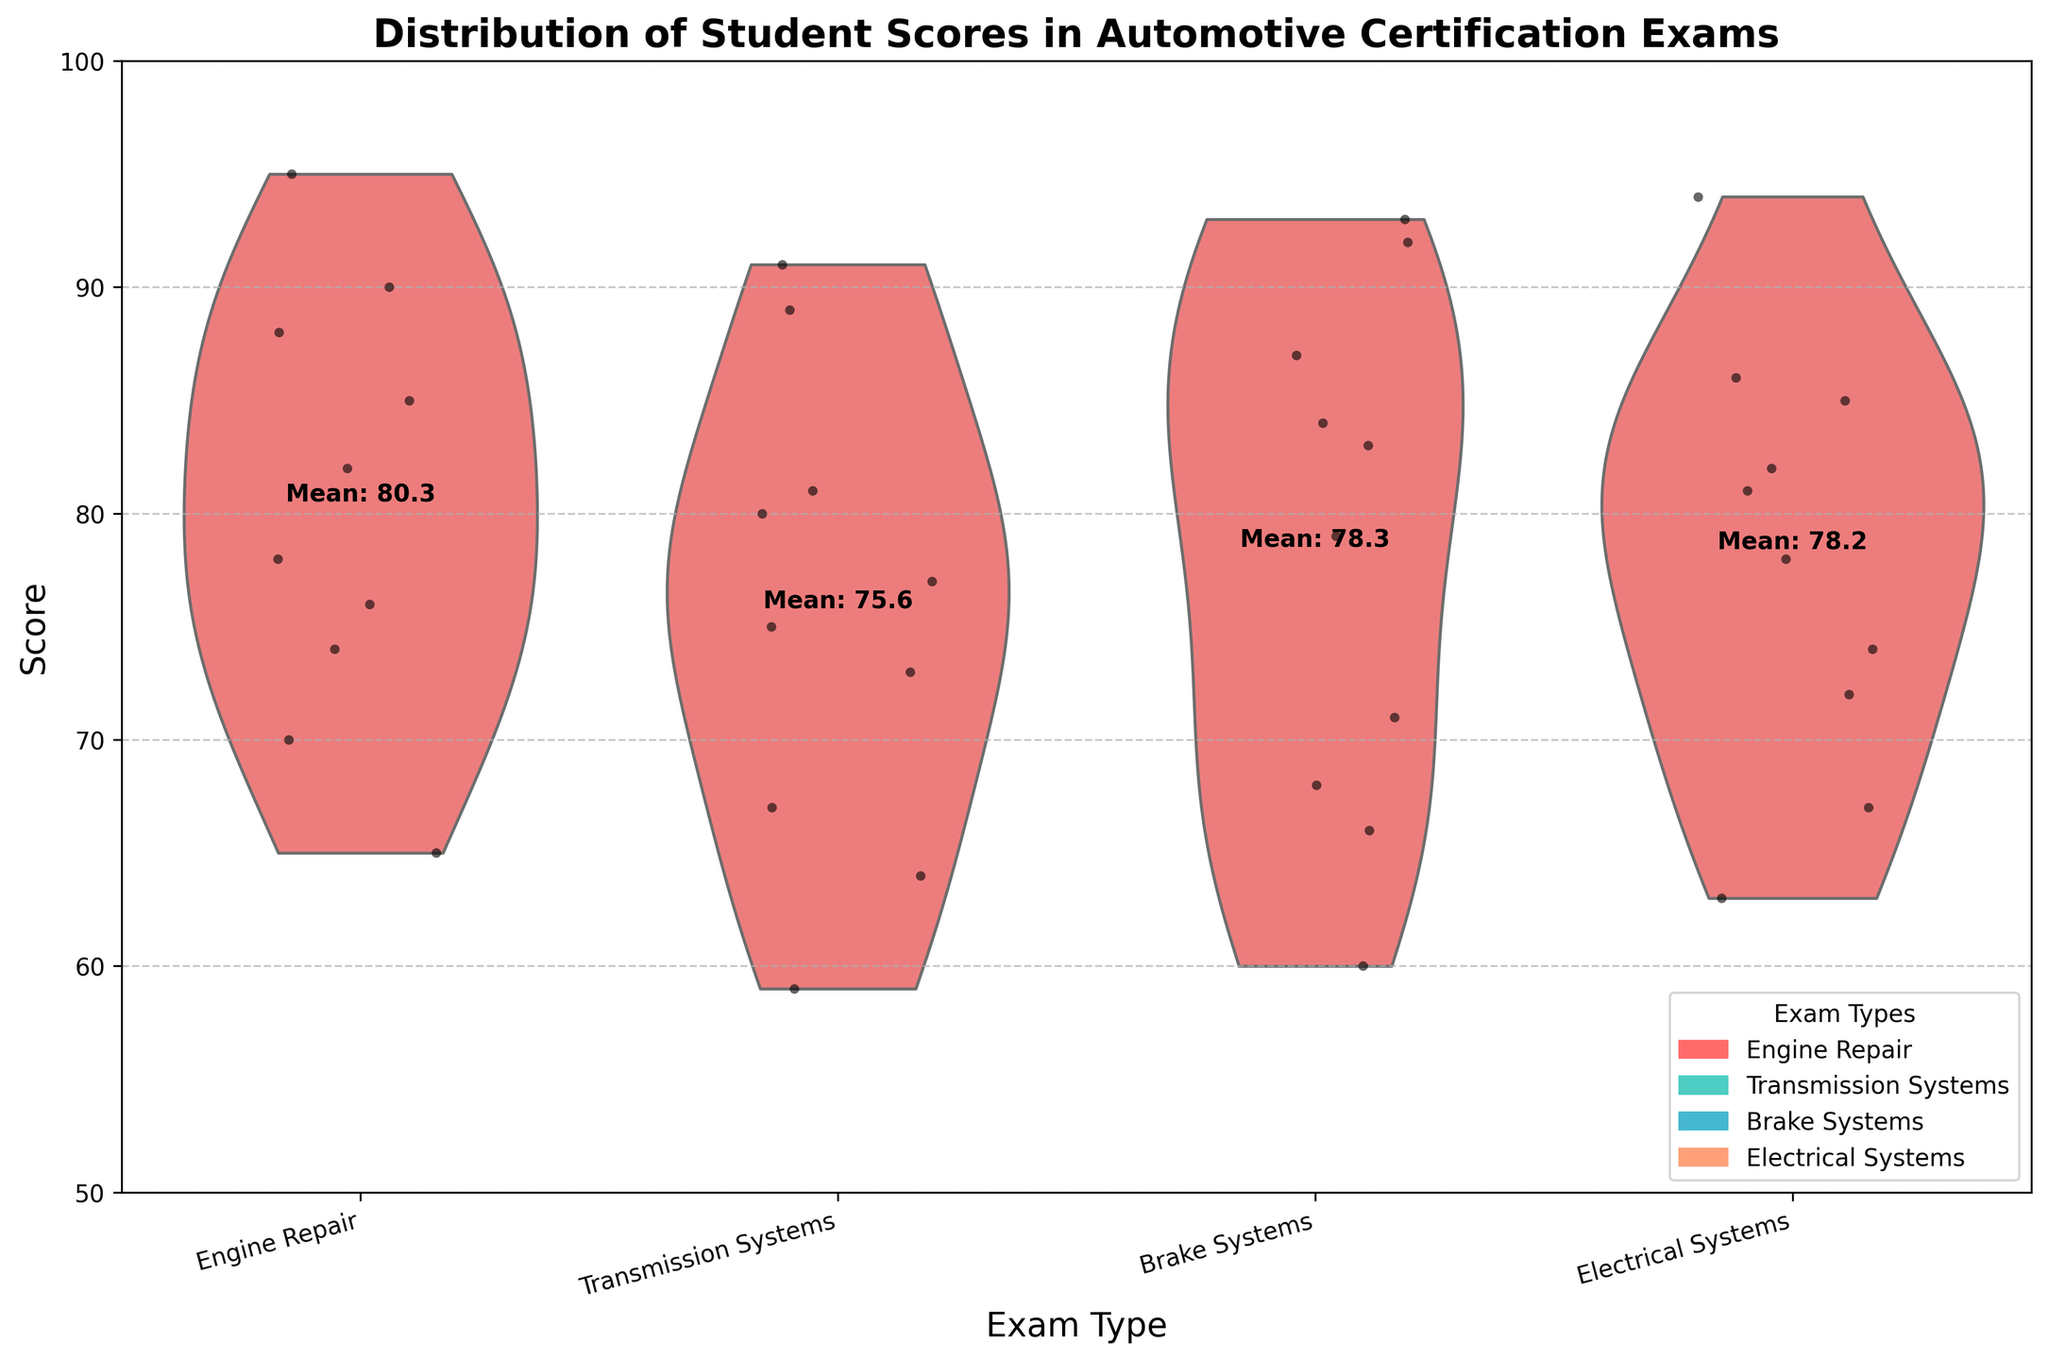What is the title of the plot? The title is displayed at the top of the plot. It summarizes the content of the plot for the viewer.
Answer: Distribution of Student Scores in Automotive Certification Exams How many exams are represented in the plot? There are four distinct exam types along the x-axis. Each represents a different type of automotive certification exam.
Answer: Four Which exam has the highest average score? The average scores for each exam type are displayed as text above the violin plots. By comparing these values, we can identify the highest one.
Answer: Brake Systems What is the range of scores for the Electrical Systems exam? The violin plot for Electrical Systems shows the distribution of scores from the bottom to the top of the shape. This visual representation helps gauge the range of scores.
Answer: 63 to 94 Which exam has the widest distribution of scores? Distribution width is visually indicated by the spread of the violin plot. The wider the plot, the more spread out the scores are.
Answer: Electrical Systems Are there more scores above or below the mean for the Transmission Systems exam? By observing the position of the jittered points relative to the mean value, indicated by the text 'Mean: 76.3', we can assess the distribution of points.
Answer: Below the mean Which exam has students who scored the lowest overall? The lowest score for each exam can be identified by looking at the bottom edge of the violin plots.
Answer: Transmission Systems Which exam shows the least point jitter? Jitter represents individual score points scattered around the central score range. The exam with the most clustered points (least scattered) reflects the least jitter.
Answer: Engine Repair What is the mean score for the Exam named 'Brake Systems'? The mean score for each exam is displayed as text above the relevant violin plot, providing a direct answer.
Answer: 79.2 How do the average scores for the Engine Repair and Electrical Systems exams compare? By comparing the mean scores displayed on the plot, we can determine the difference between these averages.
Answer: Electrical Systems has a higher mean score 